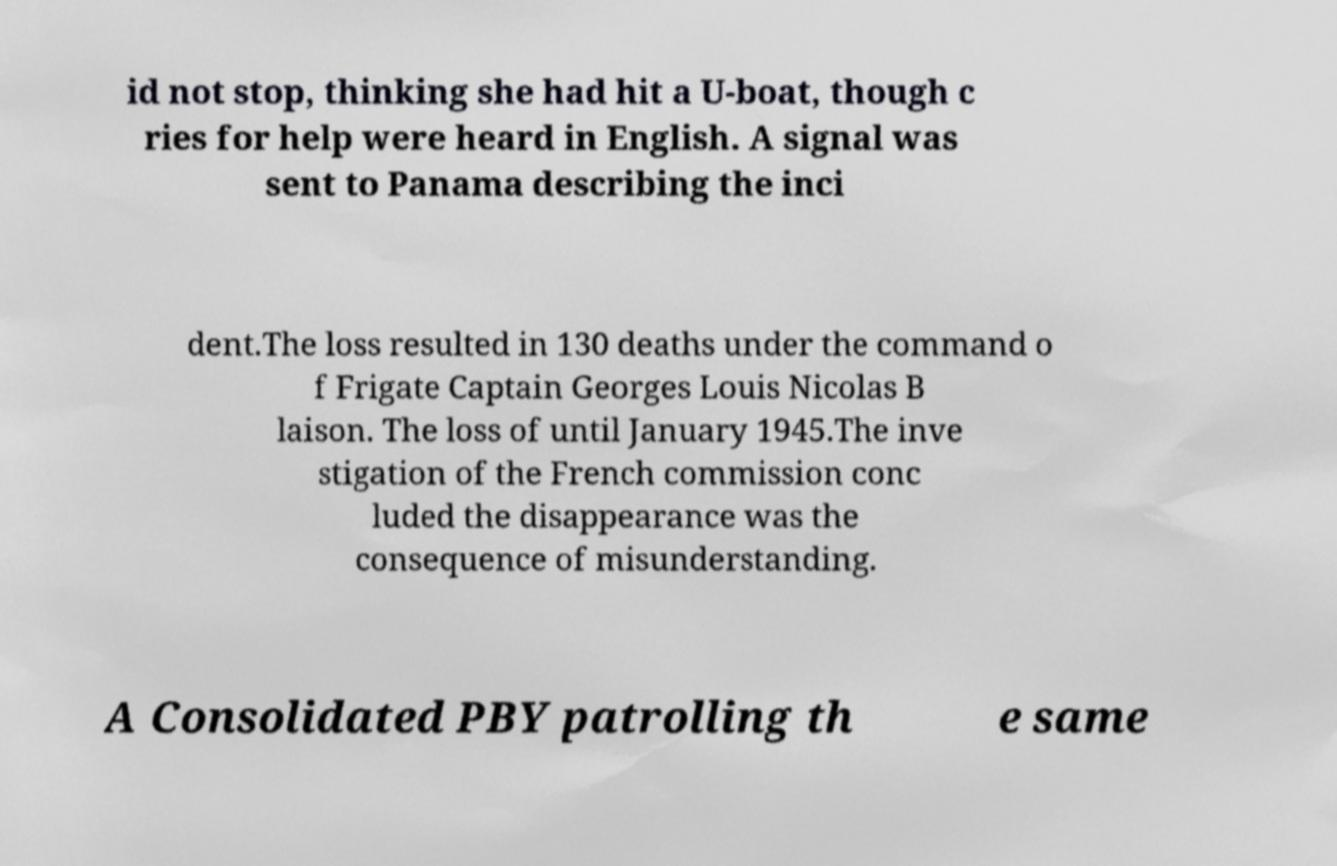What messages or text are displayed in this image? I need them in a readable, typed format. id not stop, thinking she had hit a U-boat, though c ries for help were heard in English. A signal was sent to Panama describing the inci dent.The loss resulted in 130 deaths under the command o f Frigate Captain Georges Louis Nicolas B laison. The loss of until January 1945.The inve stigation of the French commission conc luded the disappearance was the consequence of misunderstanding. A Consolidated PBY patrolling th e same 